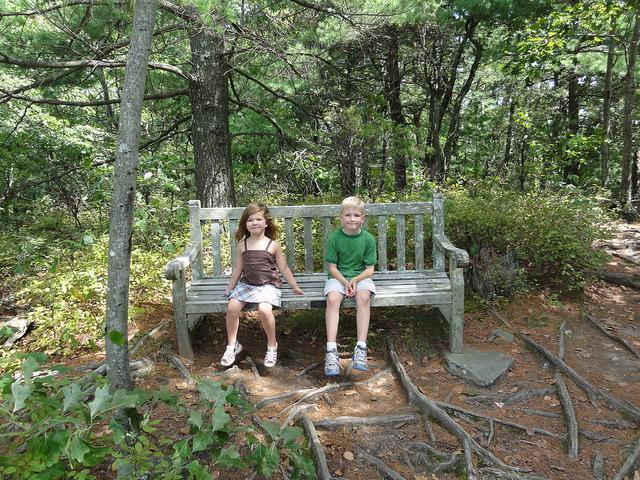What could likely happen to you on this bench?
From the following four choices, select the correct answer to address the question.
Options: Get seasick, get sunburn, get lost, sandy feet. Get sunburn. 